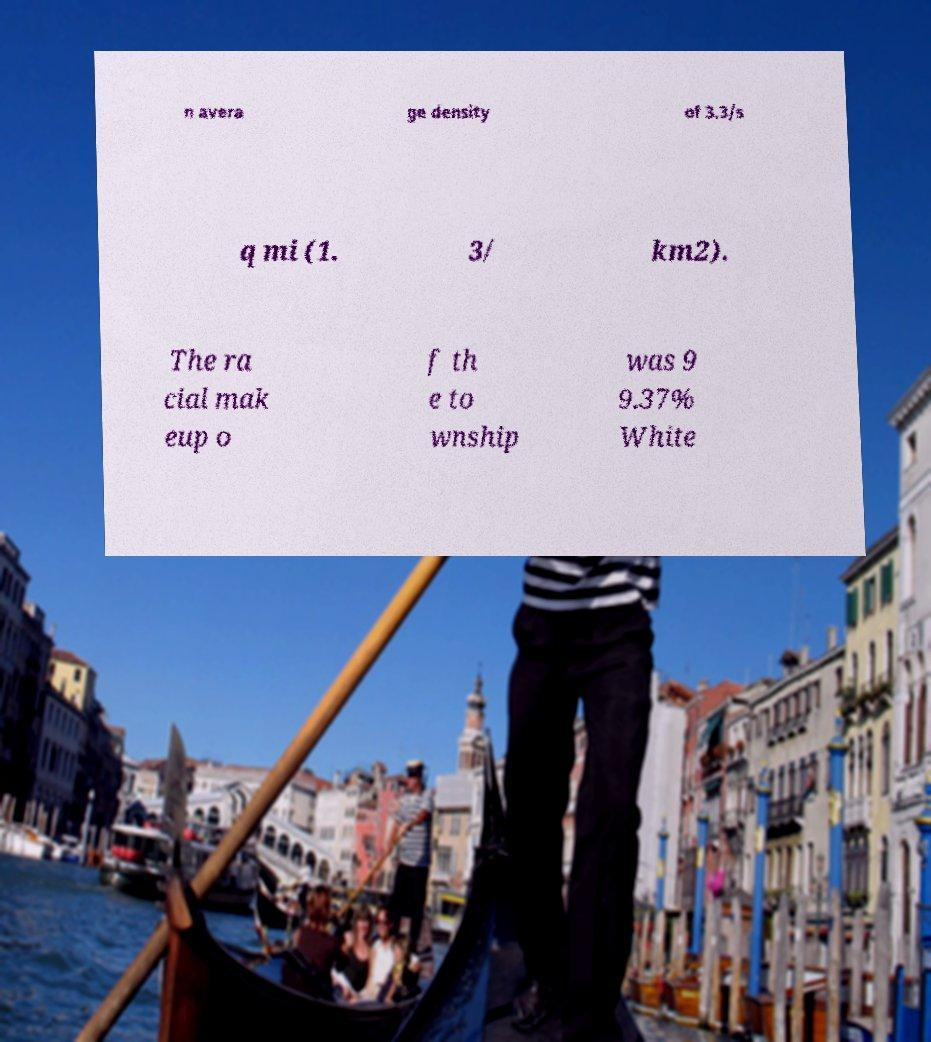Please identify and transcribe the text found in this image. n avera ge density of 3.3/s q mi (1. 3/ km2). The ra cial mak eup o f th e to wnship was 9 9.37% White 